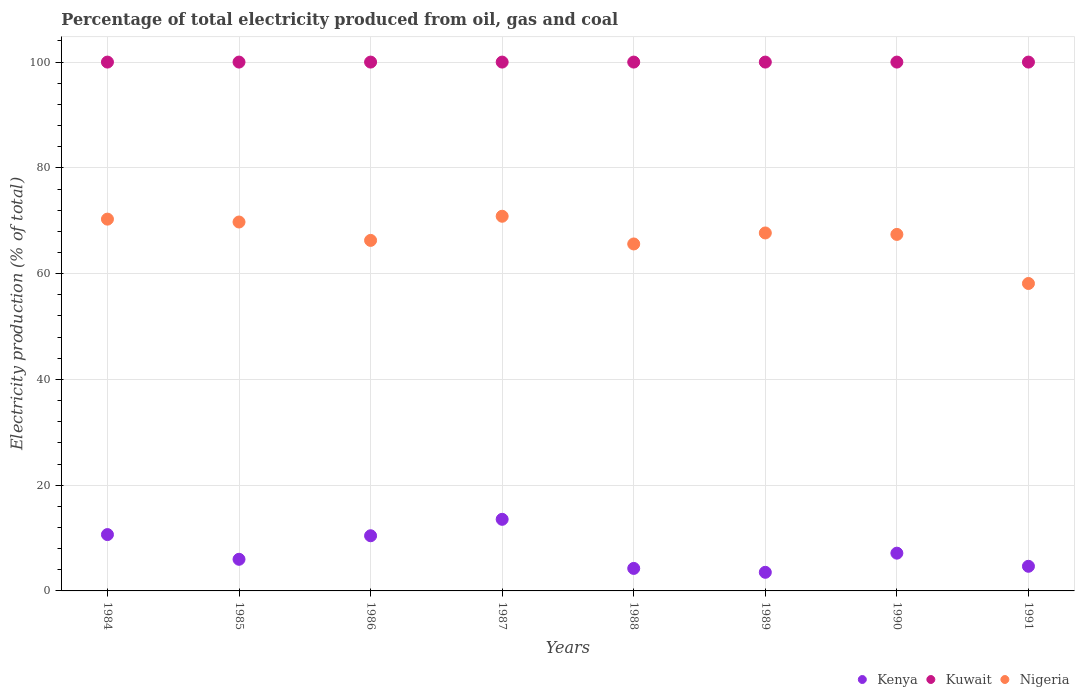How many different coloured dotlines are there?
Offer a terse response. 3. What is the electricity production in in Nigeria in 1990?
Your response must be concise. 67.41. Across all years, what is the maximum electricity production in in Kenya?
Offer a terse response. 13.54. Across all years, what is the minimum electricity production in in Kenya?
Offer a very short reply. 3.52. What is the total electricity production in in Kenya in the graph?
Your answer should be compact. 60.18. What is the difference between the electricity production in in Kenya in 1984 and the electricity production in in Nigeria in 1990?
Provide a succinct answer. -56.76. What is the average electricity production in in Kuwait per year?
Your answer should be compact. 100. In the year 1984, what is the difference between the electricity production in in Kenya and electricity production in in Kuwait?
Ensure brevity in your answer.  -89.35. In how many years, is the electricity production in in Kuwait greater than 20 %?
Your answer should be compact. 8. What is the difference between the highest and the second highest electricity production in in Kuwait?
Give a very brief answer. 0. What is the difference between the highest and the lowest electricity production in in Nigeria?
Provide a succinct answer. 12.71. In how many years, is the electricity production in in Nigeria greater than the average electricity production in in Nigeria taken over all years?
Offer a very short reply. 5. Is it the case that in every year, the sum of the electricity production in in Kuwait and electricity production in in Kenya  is greater than the electricity production in in Nigeria?
Give a very brief answer. Yes. Does the electricity production in in Nigeria monotonically increase over the years?
Your answer should be very brief. No. Is the electricity production in in Kuwait strictly greater than the electricity production in in Nigeria over the years?
Offer a terse response. Yes. How many years are there in the graph?
Your answer should be very brief. 8. What is the difference between two consecutive major ticks on the Y-axis?
Your answer should be compact. 20. Are the values on the major ticks of Y-axis written in scientific E-notation?
Keep it short and to the point. No. Does the graph contain grids?
Your response must be concise. Yes. Where does the legend appear in the graph?
Offer a terse response. Bottom right. How many legend labels are there?
Your answer should be very brief. 3. How are the legend labels stacked?
Offer a terse response. Horizontal. What is the title of the graph?
Your answer should be compact. Percentage of total electricity produced from oil, gas and coal. What is the label or title of the Y-axis?
Ensure brevity in your answer.  Electricity production (% of total). What is the Electricity production (% of total) of Kenya in 1984?
Make the answer very short. 10.65. What is the Electricity production (% of total) of Kuwait in 1984?
Ensure brevity in your answer.  100. What is the Electricity production (% of total) in Nigeria in 1984?
Provide a short and direct response. 70.3. What is the Electricity production (% of total) of Kenya in 1985?
Your response must be concise. 5.98. What is the Electricity production (% of total) of Nigeria in 1985?
Your response must be concise. 69.76. What is the Electricity production (% of total) in Kenya in 1986?
Give a very brief answer. 10.43. What is the Electricity production (% of total) in Nigeria in 1986?
Make the answer very short. 66.28. What is the Electricity production (% of total) of Kenya in 1987?
Provide a succinct answer. 13.54. What is the Electricity production (% of total) in Kuwait in 1987?
Your answer should be compact. 100. What is the Electricity production (% of total) in Nigeria in 1987?
Give a very brief answer. 70.85. What is the Electricity production (% of total) in Kenya in 1988?
Make the answer very short. 4.26. What is the Electricity production (% of total) of Nigeria in 1988?
Make the answer very short. 65.61. What is the Electricity production (% of total) of Kenya in 1989?
Provide a succinct answer. 3.52. What is the Electricity production (% of total) in Nigeria in 1989?
Provide a short and direct response. 67.69. What is the Electricity production (% of total) of Kenya in 1990?
Make the answer very short. 7.14. What is the Electricity production (% of total) in Kuwait in 1990?
Provide a short and direct response. 100. What is the Electricity production (% of total) in Nigeria in 1990?
Make the answer very short. 67.41. What is the Electricity production (% of total) of Kenya in 1991?
Offer a terse response. 4.66. What is the Electricity production (% of total) in Kuwait in 1991?
Your answer should be compact. 100. What is the Electricity production (% of total) in Nigeria in 1991?
Offer a very short reply. 58.14. Across all years, what is the maximum Electricity production (% of total) in Kenya?
Your answer should be compact. 13.54. Across all years, what is the maximum Electricity production (% of total) of Kuwait?
Keep it short and to the point. 100. Across all years, what is the maximum Electricity production (% of total) of Nigeria?
Ensure brevity in your answer.  70.85. Across all years, what is the minimum Electricity production (% of total) of Kenya?
Give a very brief answer. 3.52. Across all years, what is the minimum Electricity production (% of total) in Kuwait?
Make the answer very short. 100. Across all years, what is the minimum Electricity production (% of total) of Nigeria?
Your response must be concise. 58.14. What is the total Electricity production (% of total) of Kenya in the graph?
Provide a short and direct response. 60.18. What is the total Electricity production (% of total) of Kuwait in the graph?
Provide a short and direct response. 800. What is the total Electricity production (% of total) of Nigeria in the graph?
Make the answer very short. 536.04. What is the difference between the Electricity production (% of total) of Kenya in 1984 and that in 1985?
Offer a very short reply. 4.67. What is the difference between the Electricity production (% of total) of Kuwait in 1984 and that in 1985?
Ensure brevity in your answer.  0. What is the difference between the Electricity production (% of total) of Nigeria in 1984 and that in 1985?
Give a very brief answer. 0.54. What is the difference between the Electricity production (% of total) of Kenya in 1984 and that in 1986?
Provide a short and direct response. 0.22. What is the difference between the Electricity production (% of total) in Nigeria in 1984 and that in 1986?
Make the answer very short. 4.02. What is the difference between the Electricity production (% of total) of Kenya in 1984 and that in 1987?
Offer a very short reply. -2.89. What is the difference between the Electricity production (% of total) in Nigeria in 1984 and that in 1987?
Provide a succinct answer. -0.55. What is the difference between the Electricity production (% of total) in Kenya in 1984 and that in 1988?
Provide a short and direct response. 6.4. What is the difference between the Electricity production (% of total) of Kuwait in 1984 and that in 1988?
Your answer should be very brief. 0. What is the difference between the Electricity production (% of total) in Nigeria in 1984 and that in 1988?
Keep it short and to the point. 4.69. What is the difference between the Electricity production (% of total) in Kenya in 1984 and that in 1989?
Your answer should be very brief. 7.13. What is the difference between the Electricity production (% of total) of Nigeria in 1984 and that in 1989?
Your response must be concise. 2.61. What is the difference between the Electricity production (% of total) in Kenya in 1984 and that in 1990?
Your answer should be very brief. 3.51. What is the difference between the Electricity production (% of total) of Nigeria in 1984 and that in 1990?
Your answer should be very brief. 2.89. What is the difference between the Electricity production (% of total) of Kenya in 1984 and that in 1991?
Offer a terse response. 5.99. What is the difference between the Electricity production (% of total) in Nigeria in 1984 and that in 1991?
Provide a short and direct response. 12.17. What is the difference between the Electricity production (% of total) in Kenya in 1985 and that in 1986?
Provide a short and direct response. -4.45. What is the difference between the Electricity production (% of total) of Kuwait in 1985 and that in 1986?
Keep it short and to the point. 0. What is the difference between the Electricity production (% of total) in Nigeria in 1985 and that in 1986?
Your response must be concise. 3.48. What is the difference between the Electricity production (% of total) of Kenya in 1985 and that in 1987?
Give a very brief answer. -7.56. What is the difference between the Electricity production (% of total) of Kuwait in 1985 and that in 1987?
Provide a succinct answer. 0. What is the difference between the Electricity production (% of total) in Nigeria in 1985 and that in 1987?
Offer a very short reply. -1.09. What is the difference between the Electricity production (% of total) in Kenya in 1985 and that in 1988?
Your response must be concise. 1.72. What is the difference between the Electricity production (% of total) in Kuwait in 1985 and that in 1988?
Make the answer very short. 0. What is the difference between the Electricity production (% of total) in Nigeria in 1985 and that in 1988?
Give a very brief answer. 4.15. What is the difference between the Electricity production (% of total) in Kenya in 1985 and that in 1989?
Your response must be concise. 2.46. What is the difference between the Electricity production (% of total) of Kuwait in 1985 and that in 1989?
Give a very brief answer. 0. What is the difference between the Electricity production (% of total) of Nigeria in 1985 and that in 1989?
Ensure brevity in your answer.  2.07. What is the difference between the Electricity production (% of total) in Kenya in 1985 and that in 1990?
Ensure brevity in your answer.  -1.16. What is the difference between the Electricity production (% of total) of Kuwait in 1985 and that in 1990?
Make the answer very short. 0. What is the difference between the Electricity production (% of total) in Nigeria in 1985 and that in 1990?
Offer a very short reply. 2.34. What is the difference between the Electricity production (% of total) of Kenya in 1985 and that in 1991?
Offer a very short reply. 1.32. What is the difference between the Electricity production (% of total) of Nigeria in 1985 and that in 1991?
Make the answer very short. 11.62. What is the difference between the Electricity production (% of total) in Kenya in 1986 and that in 1987?
Make the answer very short. -3.11. What is the difference between the Electricity production (% of total) in Kuwait in 1986 and that in 1987?
Your answer should be very brief. 0. What is the difference between the Electricity production (% of total) of Nigeria in 1986 and that in 1987?
Provide a short and direct response. -4.57. What is the difference between the Electricity production (% of total) in Kenya in 1986 and that in 1988?
Make the answer very short. 6.17. What is the difference between the Electricity production (% of total) of Nigeria in 1986 and that in 1988?
Ensure brevity in your answer.  0.67. What is the difference between the Electricity production (% of total) of Kenya in 1986 and that in 1989?
Your answer should be compact. 6.91. What is the difference between the Electricity production (% of total) in Nigeria in 1986 and that in 1989?
Provide a short and direct response. -1.41. What is the difference between the Electricity production (% of total) of Kenya in 1986 and that in 1990?
Your answer should be compact. 3.29. What is the difference between the Electricity production (% of total) in Nigeria in 1986 and that in 1990?
Make the answer very short. -1.13. What is the difference between the Electricity production (% of total) of Kenya in 1986 and that in 1991?
Provide a short and direct response. 5.77. What is the difference between the Electricity production (% of total) in Nigeria in 1986 and that in 1991?
Keep it short and to the point. 8.15. What is the difference between the Electricity production (% of total) in Kenya in 1987 and that in 1988?
Make the answer very short. 9.28. What is the difference between the Electricity production (% of total) in Kuwait in 1987 and that in 1988?
Ensure brevity in your answer.  0. What is the difference between the Electricity production (% of total) of Nigeria in 1987 and that in 1988?
Ensure brevity in your answer.  5.24. What is the difference between the Electricity production (% of total) in Kenya in 1987 and that in 1989?
Provide a succinct answer. 10.02. What is the difference between the Electricity production (% of total) in Kuwait in 1987 and that in 1989?
Offer a very short reply. 0. What is the difference between the Electricity production (% of total) of Nigeria in 1987 and that in 1989?
Give a very brief answer. 3.16. What is the difference between the Electricity production (% of total) of Kenya in 1987 and that in 1990?
Offer a very short reply. 6.4. What is the difference between the Electricity production (% of total) in Nigeria in 1987 and that in 1990?
Provide a succinct answer. 3.43. What is the difference between the Electricity production (% of total) of Kenya in 1987 and that in 1991?
Provide a short and direct response. 8.88. What is the difference between the Electricity production (% of total) in Nigeria in 1987 and that in 1991?
Keep it short and to the point. 12.71. What is the difference between the Electricity production (% of total) in Kenya in 1988 and that in 1989?
Your answer should be very brief. 0.74. What is the difference between the Electricity production (% of total) in Kuwait in 1988 and that in 1989?
Ensure brevity in your answer.  0. What is the difference between the Electricity production (% of total) in Nigeria in 1988 and that in 1989?
Provide a succinct answer. -2.08. What is the difference between the Electricity production (% of total) in Kenya in 1988 and that in 1990?
Make the answer very short. -2.88. What is the difference between the Electricity production (% of total) in Nigeria in 1988 and that in 1990?
Give a very brief answer. -1.81. What is the difference between the Electricity production (% of total) of Kenya in 1988 and that in 1991?
Keep it short and to the point. -0.4. What is the difference between the Electricity production (% of total) in Nigeria in 1988 and that in 1991?
Provide a succinct answer. 7.47. What is the difference between the Electricity production (% of total) of Kenya in 1989 and that in 1990?
Offer a terse response. -3.62. What is the difference between the Electricity production (% of total) in Nigeria in 1989 and that in 1990?
Offer a very short reply. 0.27. What is the difference between the Electricity production (% of total) of Kenya in 1989 and that in 1991?
Your answer should be compact. -1.14. What is the difference between the Electricity production (% of total) of Nigeria in 1989 and that in 1991?
Your answer should be compact. 9.55. What is the difference between the Electricity production (% of total) of Kenya in 1990 and that in 1991?
Your answer should be very brief. 2.48. What is the difference between the Electricity production (% of total) of Nigeria in 1990 and that in 1991?
Offer a very short reply. 9.28. What is the difference between the Electricity production (% of total) of Kenya in 1984 and the Electricity production (% of total) of Kuwait in 1985?
Make the answer very short. -89.35. What is the difference between the Electricity production (% of total) in Kenya in 1984 and the Electricity production (% of total) in Nigeria in 1985?
Provide a short and direct response. -59.1. What is the difference between the Electricity production (% of total) in Kuwait in 1984 and the Electricity production (% of total) in Nigeria in 1985?
Ensure brevity in your answer.  30.24. What is the difference between the Electricity production (% of total) in Kenya in 1984 and the Electricity production (% of total) in Kuwait in 1986?
Offer a very short reply. -89.35. What is the difference between the Electricity production (% of total) in Kenya in 1984 and the Electricity production (% of total) in Nigeria in 1986?
Provide a short and direct response. -55.63. What is the difference between the Electricity production (% of total) in Kuwait in 1984 and the Electricity production (% of total) in Nigeria in 1986?
Your answer should be very brief. 33.72. What is the difference between the Electricity production (% of total) in Kenya in 1984 and the Electricity production (% of total) in Kuwait in 1987?
Give a very brief answer. -89.35. What is the difference between the Electricity production (% of total) of Kenya in 1984 and the Electricity production (% of total) of Nigeria in 1987?
Provide a succinct answer. -60.19. What is the difference between the Electricity production (% of total) in Kuwait in 1984 and the Electricity production (% of total) in Nigeria in 1987?
Your answer should be compact. 29.15. What is the difference between the Electricity production (% of total) in Kenya in 1984 and the Electricity production (% of total) in Kuwait in 1988?
Keep it short and to the point. -89.35. What is the difference between the Electricity production (% of total) in Kenya in 1984 and the Electricity production (% of total) in Nigeria in 1988?
Ensure brevity in your answer.  -54.95. What is the difference between the Electricity production (% of total) in Kuwait in 1984 and the Electricity production (% of total) in Nigeria in 1988?
Make the answer very short. 34.39. What is the difference between the Electricity production (% of total) of Kenya in 1984 and the Electricity production (% of total) of Kuwait in 1989?
Offer a terse response. -89.35. What is the difference between the Electricity production (% of total) in Kenya in 1984 and the Electricity production (% of total) in Nigeria in 1989?
Your response must be concise. -57.04. What is the difference between the Electricity production (% of total) of Kuwait in 1984 and the Electricity production (% of total) of Nigeria in 1989?
Your answer should be compact. 32.31. What is the difference between the Electricity production (% of total) in Kenya in 1984 and the Electricity production (% of total) in Kuwait in 1990?
Keep it short and to the point. -89.35. What is the difference between the Electricity production (% of total) of Kenya in 1984 and the Electricity production (% of total) of Nigeria in 1990?
Make the answer very short. -56.76. What is the difference between the Electricity production (% of total) of Kuwait in 1984 and the Electricity production (% of total) of Nigeria in 1990?
Ensure brevity in your answer.  32.59. What is the difference between the Electricity production (% of total) in Kenya in 1984 and the Electricity production (% of total) in Kuwait in 1991?
Make the answer very short. -89.35. What is the difference between the Electricity production (% of total) in Kenya in 1984 and the Electricity production (% of total) in Nigeria in 1991?
Provide a succinct answer. -47.48. What is the difference between the Electricity production (% of total) in Kuwait in 1984 and the Electricity production (% of total) in Nigeria in 1991?
Make the answer very short. 41.86. What is the difference between the Electricity production (% of total) in Kenya in 1985 and the Electricity production (% of total) in Kuwait in 1986?
Give a very brief answer. -94.02. What is the difference between the Electricity production (% of total) in Kenya in 1985 and the Electricity production (% of total) in Nigeria in 1986?
Your answer should be compact. -60.3. What is the difference between the Electricity production (% of total) of Kuwait in 1985 and the Electricity production (% of total) of Nigeria in 1986?
Your answer should be very brief. 33.72. What is the difference between the Electricity production (% of total) in Kenya in 1985 and the Electricity production (% of total) in Kuwait in 1987?
Make the answer very short. -94.02. What is the difference between the Electricity production (% of total) in Kenya in 1985 and the Electricity production (% of total) in Nigeria in 1987?
Give a very brief answer. -64.87. What is the difference between the Electricity production (% of total) of Kuwait in 1985 and the Electricity production (% of total) of Nigeria in 1987?
Give a very brief answer. 29.15. What is the difference between the Electricity production (% of total) in Kenya in 1985 and the Electricity production (% of total) in Kuwait in 1988?
Ensure brevity in your answer.  -94.02. What is the difference between the Electricity production (% of total) in Kenya in 1985 and the Electricity production (% of total) in Nigeria in 1988?
Offer a terse response. -59.63. What is the difference between the Electricity production (% of total) of Kuwait in 1985 and the Electricity production (% of total) of Nigeria in 1988?
Offer a very short reply. 34.39. What is the difference between the Electricity production (% of total) of Kenya in 1985 and the Electricity production (% of total) of Kuwait in 1989?
Ensure brevity in your answer.  -94.02. What is the difference between the Electricity production (% of total) of Kenya in 1985 and the Electricity production (% of total) of Nigeria in 1989?
Offer a very short reply. -61.71. What is the difference between the Electricity production (% of total) of Kuwait in 1985 and the Electricity production (% of total) of Nigeria in 1989?
Offer a very short reply. 32.31. What is the difference between the Electricity production (% of total) in Kenya in 1985 and the Electricity production (% of total) in Kuwait in 1990?
Ensure brevity in your answer.  -94.02. What is the difference between the Electricity production (% of total) of Kenya in 1985 and the Electricity production (% of total) of Nigeria in 1990?
Provide a short and direct response. -61.43. What is the difference between the Electricity production (% of total) in Kuwait in 1985 and the Electricity production (% of total) in Nigeria in 1990?
Provide a short and direct response. 32.59. What is the difference between the Electricity production (% of total) of Kenya in 1985 and the Electricity production (% of total) of Kuwait in 1991?
Your answer should be compact. -94.02. What is the difference between the Electricity production (% of total) of Kenya in 1985 and the Electricity production (% of total) of Nigeria in 1991?
Provide a succinct answer. -52.15. What is the difference between the Electricity production (% of total) in Kuwait in 1985 and the Electricity production (% of total) in Nigeria in 1991?
Your response must be concise. 41.86. What is the difference between the Electricity production (% of total) in Kenya in 1986 and the Electricity production (% of total) in Kuwait in 1987?
Give a very brief answer. -89.57. What is the difference between the Electricity production (% of total) of Kenya in 1986 and the Electricity production (% of total) of Nigeria in 1987?
Your answer should be very brief. -60.42. What is the difference between the Electricity production (% of total) of Kuwait in 1986 and the Electricity production (% of total) of Nigeria in 1987?
Make the answer very short. 29.15. What is the difference between the Electricity production (% of total) of Kenya in 1986 and the Electricity production (% of total) of Kuwait in 1988?
Offer a very short reply. -89.57. What is the difference between the Electricity production (% of total) of Kenya in 1986 and the Electricity production (% of total) of Nigeria in 1988?
Your response must be concise. -55.18. What is the difference between the Electricity production (% of total) in Kuwait in 1986 and the Electricity production (% of total) in Nigeria in 1988?
Offer a very short reply. 34.39. What is the difference between the Electricity production (% of total) of Kenya in 1986 and the Electricity production (% of total) of Kuwait in 1989?
Your answer should be compact. -89.57. What is the difference between the Electricity production (% of total) in Kenya in 1986 and the Electricity production (% of total) in Nigeria in 1989?
Your response must be concise. -57.26. What is the difference between the Electricity production (% of total) of Kuwait in 1986 and the Electricity production (% of total) of Nigeria in 1989?
Keep it short and to the point. 32.31. What is the difference between the Electricity production (% of total) in Kenya in 1986 and the Electricity production (% of total) in Kuwait in 1990?
Give a very brief answer. -89.57. What is the difference between the Electricity production (% of total) in Kenya in 1986 and the Electricity production (% of total) in Nigeria in 1990?
Your answer should be compact. -56.98. What is the difference between the Electricity production (% of total) in Kuwait in 1986 and the Electricity production (% of total) in Nigeria in 1990?
Offer a terse response. 32.59. What is the difference between the Electricity production (% of total) in Kenya in 1986 and the Electricity production (% of total) in Kuwait in 1991?
Make the answer very short. -89.57. What is the difference between the Electricity production (% of total) in Kenya in 1986 and the Electricity production (% of total) in Nigeria in 1991?
Ensure brevity in your answer.  -47.7. What is the difference between the Electricity production (% of total) in Kuwait in 1986 and the Electricity production (% of total) in Nigeria in 1991?
Offer a very short reply. 41.86. What is the difference between the Electricity production (% of total) in Kenya in 1987 and the Electricity production (% of total) in Kuwait in 1988?
Offer a very short reply. -86.46. What is the difference between the Electricity production (% of total) of Kenya in 1987 and the Electricity production (% of total) of Nigeria in 1988?
Your answer should be compact. -52.07. What is the difference between the Electricity production (% of total) in Kuwait in 1987 and the Electricity production (% of total) in Nigeria in 1988?
Your answer should be compact. 34.39. What is the difference between the Electricity production (% of total) of Kenya in 1987 and the Electricity production (% of total) of Kuwait in 1989?
Your response must be concise. -86.46. What is the difference between the Electricity production (% of total) of Kenya in 1987 and the Electricity production (% of total) of Nigeria in 1989?
Your answer should be very brief. -54.15. What is the difference between the Electricity production (% of total) of Kuwait in 1987 and the Electricity production (% of total) of Nigeria in 1989?
Offer a very short reply. 32.31. What is the difference between the Electricity production (% of total) of Kenya in 1987 and the Electricity production (% of total) of Kuwait in 1990?
Provide a short and direct response. -86.46. What is the difference between the Electricity production (% of total) in Kenya in 1987 and the Electricity production (% of total) in Nigeria in 1990?
Ensure brevity in your answer.  -53.87. What is the difference between the Electricity production (% of total) in Kuwait in 1987 and the Electricity production (% of total) in Nigeria in 1990?
Your answer should be very brief. 32.59. What is the difference between the Electricity production (% of total) of Kenya in 1987 and the Electricity production (% of total) of Kuwait in 1991?
Provide a short and direct response. -86.46. What is the difference between the Electricity production (% of total) of Kenya in 1987 and the Electricity production (% of total) of Nigeria in 1991?
Your answer should be compact. -44.59. What is the difference between the Electricity production (% of total) of Kuwait in 1987 and the Electricity production (% of total) of Nigeria in 1991?
Your answer should be compact. 41.86. What is the difference between the Electricity production (% of total) of Kenya in 1988 and the Electricity production (% of total) of Kuwait in 1989?
Make the answer very short. -95.74. What is the difference between the Electricity production (% of total) of Kenya in 1988 and the Electricity production (% of total) of Nigeria in 1989?
Provide a succinct answer. -63.43. What is the difference between the Electricity production (% of total) in Kuwait in 1988 and the Electricity production (% of total) in Nigeria in 1989?
Offer a very short reply. 32.31. What is the difference between the Electricity production (% of total) of Kenya in 1988 and the Electricity production (% of total) of Kuwait in 1990?
Offer a terse response. -95.74. What is the difference between the Electricity production (% of total) of Kenya in 1988 and the Electricity production (% of total) of Nigeria in 1990?
Offer a very short reply. -63.16. What is the difference between the Electricity production (% of total) of Kuwait in 1988 and the Electricity production (% of total) of Nigeria in 1990?
Your answer should be compact. 32.59. What is the difference between the Electricity production (% of total) in Kenya in 1988 and the Electricity production (% of total) in Kuwait in 1991?
Make the answer very short. -95.74. What is the difference between the Electricity production (% of total) in Kenya in 1988 and the Electricity production (% of total) in Nigeria in 1991?
Your answer should be very brief. -53.88. What is the difference between the Electricity production (% of total) of Kuwait in 1988 and the Electricity production (% of total) of Nigeria in 1991?
Offer a very short reply. 41.86. What is the difference between the Electricity production (% of total) in Kenya in 1989 and the Electricity production (% of total) in Kuwait in 1990?
Ensure brevity in your answer.  -96.48. What is the difference between the Electricity production (% of total) of Kenya in 1989 and the Electricity production (% of total) of Nigeria in 1990?
Ensure brevity in your answer.  -63.89. What is the difference between the Electricity production (% of total) in Kuwait in 1989 and the Electricity production (% of total) in Nigeria in 1990?
Offer a very short reply. 32.59. What is the difference between the Electricity production (% of total) of Kenya in 1989 and the Electricity production (% of total) of Kuwait in 1991?
Offer a very short reply. -96.48. What is the difference between the Electricity production (% of total) of Kenya in 1989 and the Electricity production (% of total) of Nigeria in 1991?
Offer a terse response. -54.61. What is the difference between the Electricity production (% of total) of Kuwait in 1989 and the Electricity production (% of total) of Nigeria in 1991?
Keep it short and to the point. 41.86. What is the difference between the Electricity production (% of total) in Kenya in 1990 and the Electricity production (% of total) in Kuwait in 1991?
Ensure brevity in your answer.  -92.86. What is the difference between the Electricity production (% of total) of Kenya in 1990 and the Electricity production (% of total) of Nigeria in 1991?
Offer a terse response. -50.99. What is the difference between the Electricity production (% of total) in Kuwait in 1990 and the Electricity production (% of total) in Nigeria in 1991?
Offer a terse response. 41.86. What is the average Electricity production (% of total) of Kenya per year?
Your response must be concise. 7.52. What is the average Electricity production (% of total) of Kuwait per year?
Offer a very short reply. 100. What is the average Electricity production (% of total) in Nigeria per year?
Your response must be concise. 67. In the year 1984, what is the difference between the Electricity production (% of total) in Kenya and Electricity production (% of total) in Kuwait?
Provide a succinct answer. -89.35. In the year 1984, what is the difference between the Electricity production (% of total) of Kenya and Electricity production (% of total) of Nigeria?
Keep it short and to the point. -59.65. In the year 1984, what is the difference between the Electricity production (% of total) in Kuwait and Electricity production (% of total) in Nigeria?
Ensure brevity in your answer.  29.7. In the year 1985, what is the difference between the Electricity production (% of total) of Kenya and Electricity production (% of total) of Kuwait?
Provide a short and direct response. -94.02. In the year 1985, what is the difference between the Electricity production (% of total) in Kenya and Electricity production (% of total) in Nigeria?
Give a very brief answer. -63.78. In the year 1985, what is the difference between the Electricity production (% of total) in Kuwait and Electricity production (% of total) in Nigeria?
Make the answer very short. 30.24. In the year 1986, what is the difference between the Electricity production (% of total) of Kenya and Electricity production (% of total) of Kuwait?
Keep it short and to the point. -89.57. In the year 1986, what is the difference between the Electricity production (% of total) in Kenya and Electricity production (% of total) in Nigeria?
Offer a very short reply. -55.85. In the year 1986, what is the difference between the Electricity production (% of total) of Kuwait and Electricity production (% of total) of Nigeria?
Keep it short and to the point. 33.72. In the year 1987, what is the difference between the Electricity production (% of total) in Kenya and Electricity production (% of total) in Kuwait?
Provide a short and direct response. -86.46. In the year 1987, what is the difference between the Electricity production (% of total) of Kenya and Electricity production (% of total) of Nigeria?
Make the answer very short. -57.31. In the year 1987, what is the difference between the Electricity production (% of total) in Kuwait and Electricity production (% of total) in Nigeria?
Offer a terse response. 29.15. In the year 1988, what is the difference between the Electricity production (% of total) in Kenya and Electricity production (% of total) in Kuwait?
Your answer should be very brief. -95.74. In the year 1988, what is the difference between the Electricity production (% of total) in Kenya and Electricity production (% of total) in Nigeria?
Ensure brevity in your answer.  -61.35. In the year 1988, what is the difference between the Electricity production (% of total) of Kuwait and Electricity production (% of total) of Nigeria?
Your answer should be compact. 34.39. In the year 1989, what is the difference between the Electricity production (% of total) of Kenya and Electricity production (% of total) of Kuwait?
Offer a terse response. -96.48. In the year 1989, what is the difference between the Electricity production (% of total) of Kenya and Electricity production (% of total) of Nigeria?
Provide a succinct answer. -64.17. In the year 1989, what is the difference between the Electricity production (% of total) of Kuwait and Electricity production (% of total) of Nigeria?
Give a very brief answer. 32.31. In the year 1990, what is the difference between the Electricity production (% of total) of Kenya and Electricity production (% of total) of Kuwait?
Offer a very short reply. -92.86. In the year 1990, what is the difference between the Electricity production (% of total) in Kenya and Electricity production (% of total) in Nigeria?
Your answer should be compact. -60.27. In the year 1990, what is the difference between the Electricity production (% of total) of Kuwait and Electricity production (% of total) of Nigeria?
Offer a terse response. 32.59. In the year 1991, what is the difference between the Electricity production (% of total) in Kenya and Electricity production (% of total) in Kuwait?
Give a very brief answer. -95.34. In the year 1991, what is the difference between the Electricity production (% of total) in Kenya and Electricity production (% of total) in Nigeria?
Provide a succinct answer. -53.48. In the year 1991, what is the difference between the Electricity production (% of total) in Kuwait and Electricity production (% of total) in Nigeria?
Keep it short and to the point. 41.86. What is the ratio of the Electricity production (% of total) of Kenya in 1984 to that in 1985?
Your answer should be very brief. 1.78. What is the ratio of the Electricity production (% of total) of Kuwait in 1984 to that in 1985?
Provide a short and direct response. 1. What is the ratio of the Electricity production (% of total) of Nigeria in 1984 to that in 1985?
Ensure brevity in your answer.  1.01. What is the ratio of the Electricity production (% of total) of Kenya in 1984 to that in 1986?
Offer a terse response. 1.02. What is the ratio of the Electricity production (% of total) in Kuwait in 1984 to that in 1986?
Your answer should be compact. 1. What is the ratio of the Electricity production (% of total) of Nigeria in 1984 to that in 1986?
Keep it short and to the point. 1.06. What is the ratio of the Electricity production (% of total) in Kenya in 1984 to that in 1987?
Ensure brevity in your answer.  0.79. What is the ratio of the Electricity production (% of total) in Nigeria in 1984 to that in 1987?
Make the answer very short. 0.99. What is the ratio of the Electricity production (% of total) in Kenya in 1984 to that in 1988?
Provide a succinct answer. 2.5. What is the ratio of the Electricity production (% of total) of Kuwait in 1984 to that in 1988?
Offer a very short reply. 1. What is the ratio of the Electricity production (% of total) in Nigeria in 1984 to that in 1988?
Your answer should be compact. 1.07. What is the ratio of the Electricity production (% of total) of Kenya in 1984 to that in 1989?
Ensure brevity in your answer.  3.03. What is the ratio of the Electricity production (% of total) of Kuwait in 1984 to that in 1989?
Provide a succinct answer. 1. What is the ratio of the Electricity production (% of total) in Nigeria in 1984 to that in 1989?
Your response must be concise. 1.04. What is the ratio of the Electricity production (% of total) of Kenya in 1984 to that in 1990?
Your response must be concise. 1.49. What is the ratio of the Electricity production (% of total) of Kuwait in 1984 to that in 1990?
Offer a terse response. 1. What is the ratio of the Electricity production (% of total) of Nigeria in 1984 to that in 1990?
Your answer should be very brief. 1.04. What is the ratio of the Electricity production (% of total) in Kenya in 1984 to that in 1991?
Your answer should be very brief. 2.29. What is the ratio of the Electricity production (% of total) in Kuwait in 1984 to that in 1991?
Provide a succinct answer. 1. What is the ratio of the Electricity production (% of total) of Nigeria in 1984 to that in 1991?
Offer a terse response. 1.21. What is the ratio of the Electricity production (% of total) of Kenya in 1985 to that in 1986?
Your answer should be very brief. 0.57. What is the ratio of the Electricity production (% of total) in Nigeria in 1985 to that in 1986?
Ensure brevity in your answer.  1.05. What is the ratio of the Electricity production (% of total) in Kenya in 1985 to that in 1987?
Ensure brevity in your answer.  0.44. What is the ratio of the Electricity production (% of total) in Nigeria in 1985 to that in 1987?
Provide a short and direct response. 0.98. What is the ratio of the Electricity production (% of total) in Kenya in 1985 to that in 1988?
Offer a very short reply. 1.41. What is the ratio of the Electricity production (% of total) in Nigeria in 1985 to that in 1988?
Your answer should be compact. 1.06. What is the ratio of the Electricity production (% of total) of Kenya in 1985 to that in 1989?
Ensure brevity in your answer.  1.7. What is the ratio of the Electricity production (% of total) in Nigeria in 1985 to that in 1989?
Your answer should be very brief. 1.03. What is the ratio of the Electricity production (% of total) in Kenya in 1985 to that in 1990?
Provide a short and direct response. 0.84. What is the ratio of the Electricity production (% of total) in Kuwait in 1985 to that in 1990?
Offer a terse response. 1. What is the ratio of the Electricity production (% of total) in Nigeria in 1985 to that in 1990?
Keep it short and to the point. 1.03. What is the ratio of the Electricity production (% of total) in Kenya in 1985 to that in 1991?
Offer a terse response. 1.28. What is the ratio of the Electricity production (% of total) in Kuwait in 1985 to that in 1991?
Keep it short and to the point. 1. What is the ratio of the Electricity production (% of total) of Nigeria in 1985 to that in 1991?
Provide a succinct answer. 1.2. What is the ratio of the Electricity production (% of total) in Kenya in 1986 to that in 1987?
Offer a terse response. 0.77. What is the ratio of the Electricity production (% of total) of Kuwait in 1986 to that in 1987?
Your answer should be very brief. 1. What is the ratio of the Electricity production (% of total) in Nigeria in 1986 to that in 1987?
Keep it short and to the point. 0.94. What is the ratio of the Electricity production (% of total) in Kenya in 1986 to that in 1988?
Your answer should be very brief. 2.45. What is the ratio of the Electricity production (% of total) of Nigeria in 1986 to that in 1988?
Provide a succinct answer. 1.01. What is the ratio of the Electricity production (% of total) of Kenya in 1986 to that in 1989?
Offer a very short reply. 2.96. What is the ratio of the Electricity production (% of total) in Kuwait in 1986 to that in 1989?
Ensure brevity in your answer.  1. What is the ratio of the Electricity production (% of total) of Nigeria in 1986 to that in 1989?
Provide a short and direct response. 0.98. What is the ratio of the Electricity production (% of total) in Kenya in 1986 to that in 1990?
Keep it short and to the point. 1.46. What is the ratio of the Electricity production (% of total) in Kuwait in 1986 to that in 1990?
Provide a succinct answer. 1. What is the ratio of the Electricity production (% of total) in Nigeria in 1986 to that in 1990?
Offer a terse response. 0.98. What is the ratio of the Electricity production (% of total) in Kenya in 1986 to that in 1991?
Offer a terse response. 2.24. What is the ratio of the Electricity production (% of total) of Nigeria in 1986 to that in 1991?
Give a very brief answer. 1.14. What is the ratio of the Electricity production (% of total) of Kenya in 1987 to that in 1988?
Provide a succinct answer. 3.18. What is the ratio of the Electricity production (% of total) of Kuwait in 1987 to that in 1988?
Provide a succinct answer. 1. What is the ratio of the Electricity production (% of total) of Nigeria in 1987 to that in 1988?
Provide a short and direct response. 1.08. What is the ratio of the Electricity production (% of total) of Kenya in 1987 to that in 1989?
Offer a very short reply. 3.85. What is the ratio of the Electricity production (% of total) in Nigeria in 1987 to that in 1989?
Give a very brief answer. 1.05. What is the ratio of the Electricity production (% of total) in Kenya in 1987 to that in 1990?
Your answer should be compact. 1.9. What is the ratio of the Electricity production (% of total) in Kuwait in 1987 to that in 1990?
Offer a terse response. 1. What is the ratio of the Electricity production (% of total) of Nigeria in 1987 to that in 1990?
Your answer should be very brief. 1.05. What is the ratio of the Electricity production (% of total) of Kenya in 1987 to that in 1991?
Your response must be concise. 2.91. What is the ratio of the Electricity production (% of total) of Kuwait in 1987 to that in 1991?
Make the answer very short. 1. What is the ratio of the Electricity production (% of total) of Nigeria in 1987 to that in 1991?
Give a very brief answer. 1.22. What is the ratio of the Electricity production (% of total) of Kenya in 1988 to that in 1989?
Provide a succinct answer. 1.21. What is the ratio of the Electricity production (% of total) in Kuwait in 1988 to that in 1989?
Offer a very short reply. 1. What is the ratio of the Electricity production (% of total) of Nigeria in 1988 to that in 1989?
Provide a succinct answer. 0.97. What is the ratio of the Electricity production (% of total) of Kenya in 1988 to that in 1990?
Offer a very short reply. 0.6. What is the ratio of the Electricity production (% of total) in Kuwait in 1988 to that in 1990?
Keep it short and to the point. 1. What is the ratio of the Electricity production (% of total) in Nigeria in 1988 to that in 1990?
Offer a very short reply. 0.97. What is the ratio of the Electricity production (% of total) of Kenya in 1988 to that in 1991?
Provide a short and direct response. 0.91. What is the ratio of the Electricity production (% of total) of Nigeria in 1988 to that in 1991?
Your response must be concise. 1.13. What is the ratio of the Electricity production (% of total) in Kenya in 1989 to that in 1990?
Provide a short and direct response. 0.49. What is the ratio of the Electricity production (% of total) of Kenya in 1989 to that in 1991?
Provide a short and direct response. 0.76. What is the ratio of the Electricity production (% of total) in Kuwait in 1989 to that in 1991?
Ensure brevity in your answer.  1. What is the ratio of the Electricity production (% of total) of Nigeria in 1989 to that in 1991?
Give a very brief answer. 1.16. What is the ratio of the Electricity production (% of total) of Kenya in 1990 to that in 1991?
Ensure brevity in your answer.  1.53. What is the ratio of the Electricity production (% of total) of Nigeria in 1990 to that in 1991?
Offer a terse response. 1.16. What is the difference between the highest and the second highest Electricity production (% of total) in Kenya?
Provide a succinct answer. 2.89. What is the difference between the highest and the second highest Electricity production (% of total) in Nigeria?
Keep it short and to the point. 0.55. What is the difference between the highest and the lowest Electricity production (% of total) of Kenya?
Your answer should be compact. 10.02. What is the difference between the highest and the lowest Electricity production (% of total) in Kuwait?
Make the answer very short. 0. What is the difference between the highest and the lowest Electricity production (% of total) in Nigeria?
Provide a short and direct response. 12.71. 